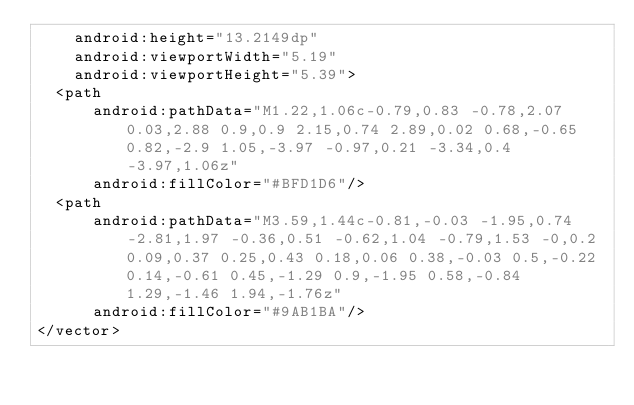<code> <loc_0><loc_0><loc_500><loc_500><_XML_>    android:height="13.2149dp"
    android:viewportWidth="5.19"
    android:viewportHeight="5.39">
  <path
      android:pathData="M1.22,1.06c-0.79,0.83 -0.78,2.07 0.03,2.88 0.9,0.9 2.15,0.74 2.89,0.02 0.68,-0.65 0.82,-2.9 1.05,-3.97 -0.97,0.21 -3.34,0.4 -3.97,1.06z"
      android:fillColor="#BFD1D6"/>
  <path
      android:pathData="M3.59,1.44c-0.81,-0.03 -1.95,0.74 -2.81,1.97 -0.36,0.51 -0.62,1.04 -0.79,1.53 -0,0.2 0.09,0.37 0.25,0.43 0.18,0.06 0.38,-0.03 0.5,-0.22 0.14,-0.61 0.45,-1.29 0.9,-1.95 0.58,-0.84 1.29,-1.46 1.94,-1.76z"
      android:fillColor="#9AB1BA"/>
</vector>
</code> 